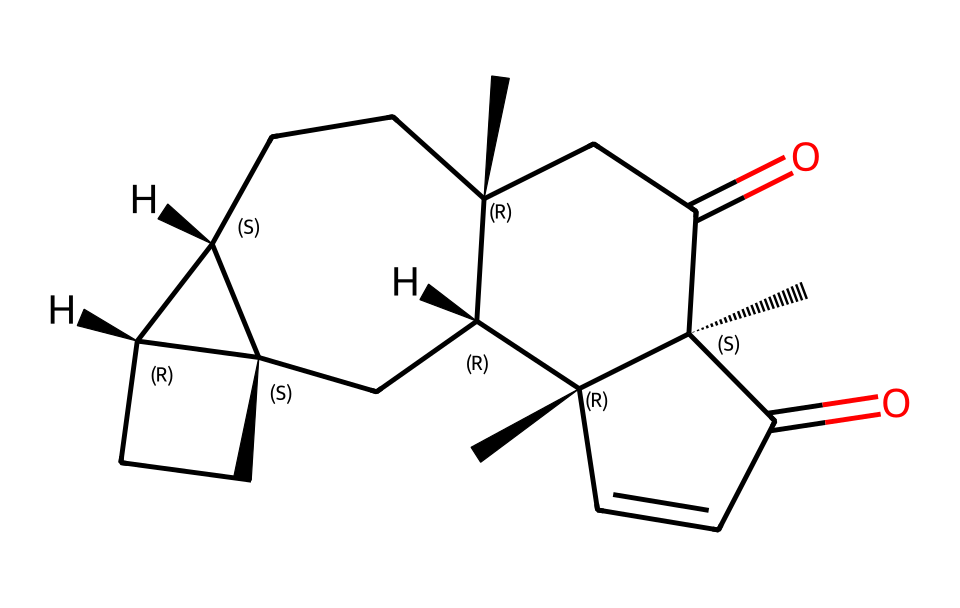What is the core structure of this chemical? The core structure is based on steroids, indicated by the fused ring system evident in the SMILES representation which suggests multiple cycloalkane rings.
Answer: steroid How many chiral centers does this chemical have? By analyzing the SMILES, we can see that there are four stereocenters indicated by the "@" symbols. Each "@" indicates a chiral carbon in the molecule.
Answer: four What type of molecules does this chemical primarily interact with? Given its structure, this chemical primarily interacts with hormone receptors, as it resembles both estrogen and testosterone in structure.
Answer: hormone receptors What functional groups are present in this chemical? The presence of ketones (indicated by the "O="), along with cyclic structures, highlights functional groups that include ketone groups.
Answer: ketone Is this chemical hydrophilic or hydrophobic? The overall structure is largely hydrophobic due to the carbon chains and rings present, making it less likely to interact with water.
Answer: hydrophobic 